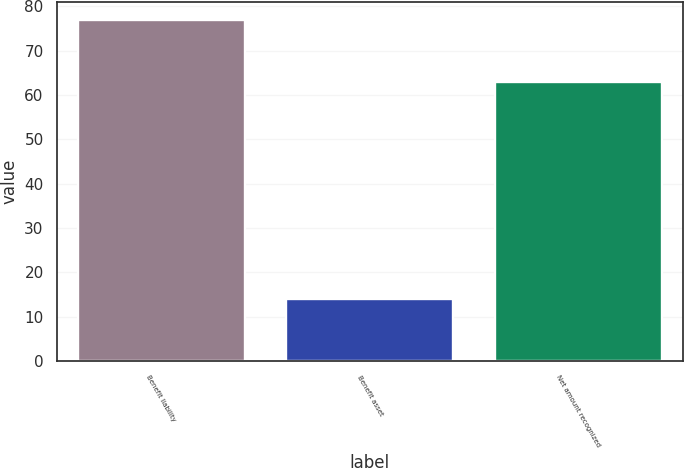Convert chart. <chart><loc_0><loc_0><loc_500><loc_500><bar_chart><fcel>Benefit liability<fcel>Benefit asset<fcel>Net amount recognized<nl><fcel>77<fcel>14<fcel>63<nl></chart> 